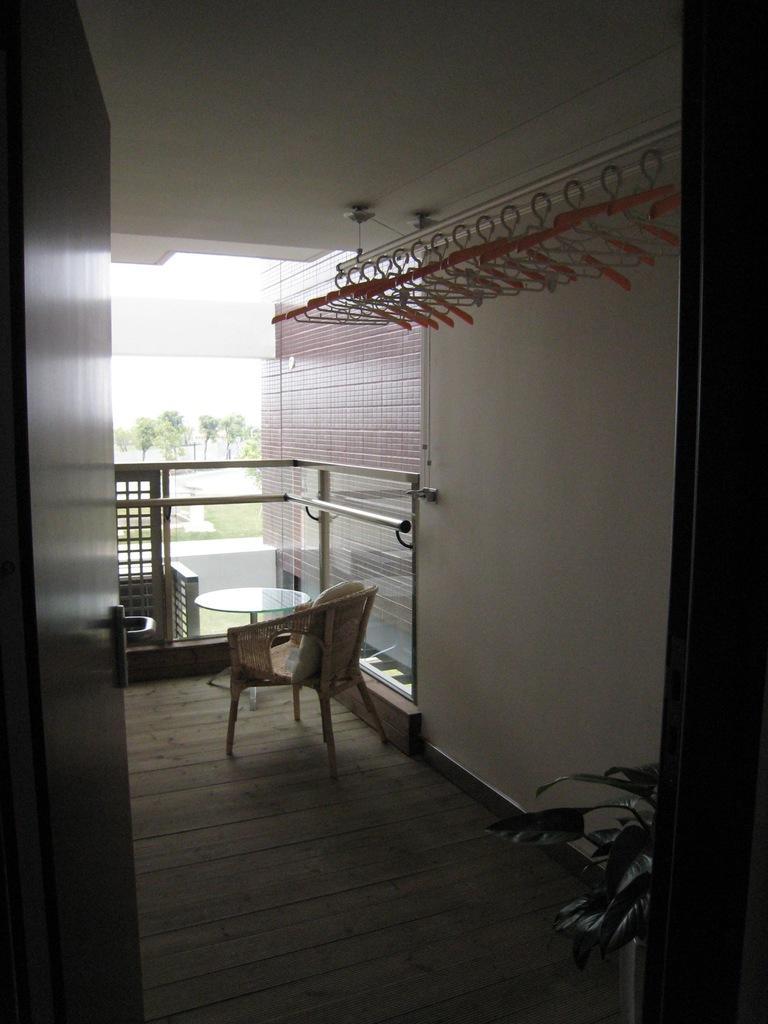In one or two sentences, can you explain what this image depicts? In this image we can see table, chair, wall, fencing, hangers, door, trees and sky. 